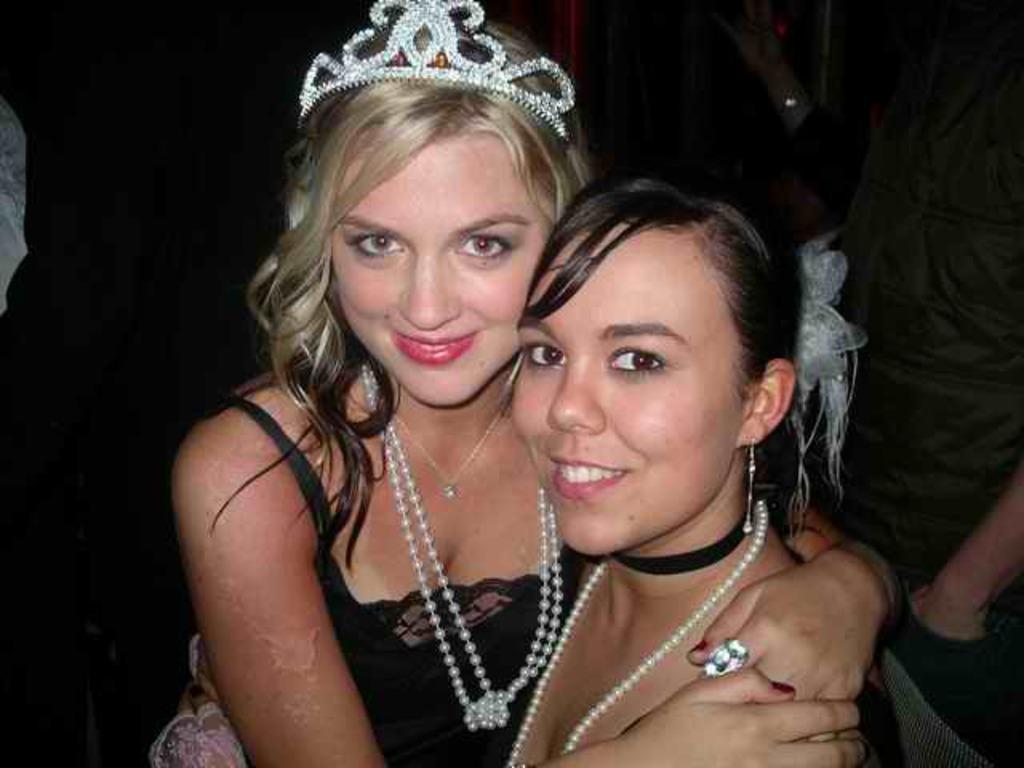Can you describe this image briefly? In this picture there are two girls in the center of the image and there are other people in the background area of the image. 